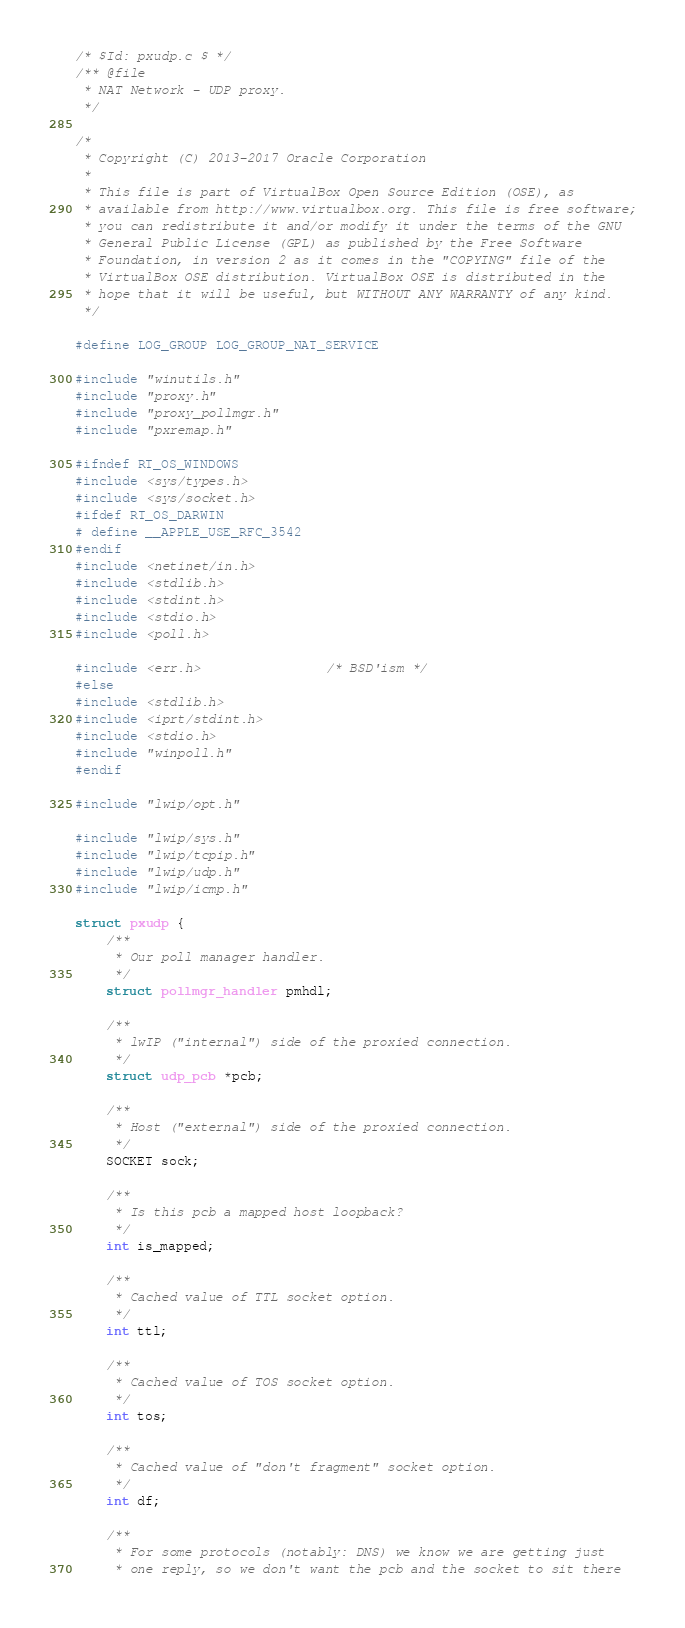<code> <loc_0><loc_0><loc_500><loc_500><_C_>/* $Id: pxudp.c $ */
/** @file
 * NAT Network - UDP proxy.
 */

/*
 * Copyright (C) 2013-2017 Oracle Corporation
 *
 * This file is part of VirtualBox Open Source Edition (OSE), as
 * available from http://www.virtualbox.org. This file is free software;
 * you can redistribute it and/or modify it under the terms of the GNU
 * General Public License (GPL) as published by the Free Software
 * Foundation, in version 2 as it comes in the "COPYING" file of the
 * VirtualBox OSE distribution. VirtualBox OSE is distributed in the
 * hope that it will be useful, but WITHOUT ANY WARRANTY of any kind.
 */

#define LOG_GROUP LOG_GROUP_NAT_SERVICE

#include "winutils.h"
#include "proxy.h"
#include "proxy_pollmgr.h"
#include "pxremap.h"

#ifndef RT_OS_WINDOWS
#include <sys/types.h>
#include <sys/socket.h>
#ifdef RT_OS_DARWIN
# define __APPLE_USE_RFC_3542
#endif
#include <netinet/in.h>
#include <stdlib.h>
#include <stdint.h>
#include <stdio.h>
#include <poll.h>

#include <err.h>                /* BSD'ism */
#else
#include <stdlib.h>
#include <iprt/stdint.h>
#include <stdio.h>
#include "winpoll.h"
#endif

#include "lwip/opt.h"

#include "lwip/sys.h"
#include "lwip/tcpip.h"
#include "lwip/udp.h"
#include "lwip/icmp.h"

struct pxudp {
    /**
     * Our poll manager handler.
     */
    struct pollmgr_handler pmhdl;

    /**
     * lwIP ("internal") side of the proxied connection.
     */
    struct udp_pcb *pcb;

    /**
     * Host ("external") side of the proxied connection.
     */
    SOCKET sock;

    /**
     * Is this pcb a mapped host loopback?
     */
    int is_mapped;

    /**
     * Cached value of TTL socket option.
     */
    int ttl;

    /**
     * Cached value of TOS socket option.
     */
    int tos;

    /**
     * Cached value of "don't fragment" socket option.
     */
    int df;

    /**
     * For some protocols (notably: DNS) we know we are getting just
     * one reply, so we don't want the pcb and the socket to sit there</code> 